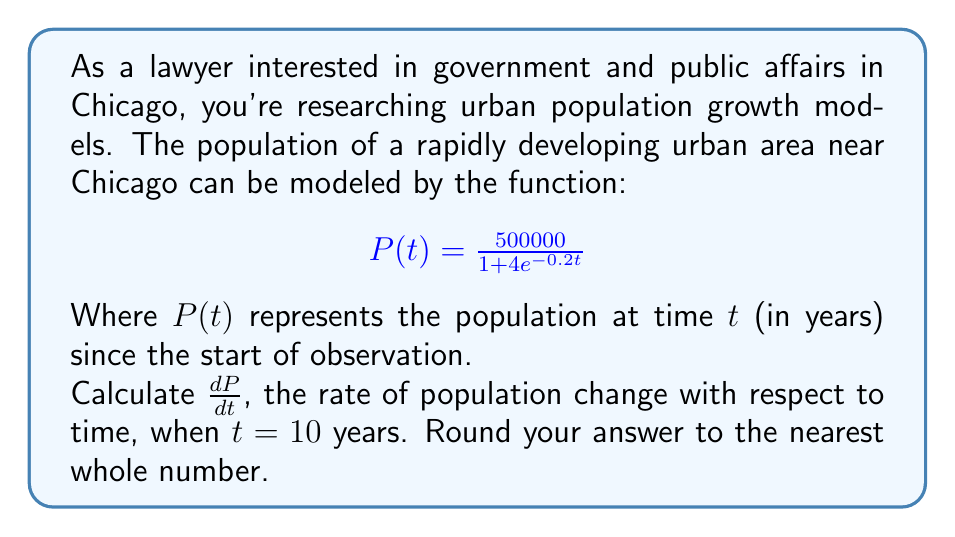Can you solve this math problem? To solve this problem, we'll follow these steps:

1) First, we need to find the derivative of $P(t)$ with respect to $t$. We can use the quotient rule:

   If $f(t) = \frac{u(t)}{v(t)}$, then $f'(t) = \frac{u'(t)v(t) - u(t)v'(t)}{[v(t)]^2}$

2) In our case:
   $u(t) = 500000$ (constant)
   $v(t) = 1 + 4e^{-0.2t}$

3) We calculate:
   $u'(t) = 0$ (derivative of a constant is 0)
   $v'(t) = 4(-0.2)e^{-0.2t} = -0.8e^{-0.2t}$ (using chain rule)

4) Applying the quotient rule:

   $$\frac{dP}{dt} = \frac{0(1 + 4e^{-0.2t}) - 500000(-0.8e^{-0.2t})}{(1 + 4e^{-0.2t})^2}$$

5) Simplifying:

   $$\frac{dP}{dt} = \frac{400000e^{-0.2t}}{(1 + 4e^{-0.2t})^2}$$

6) Now we need to evaluate this at $t = 10$:

   $$\frac{dP}{dt}\bigg|_{t=10} = \frac{400000e^{-2}}{(1 + 4e^{-2})^2}$$

7) Calculate this value:
   $e^{-2} \approx 0.1353$
   $1 + 4e^{-2} \approx 1.5412$

   $$\frac{dP}{dt}\bigg|_{t=10} \approx \frac{400000(0.1353)}{(1.5412)^2} \approx 22781.95$$

8) Rounding to the nearest whole number: 22782
Answer: 22782 